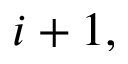<formula> <loc_0><loc_0><loc_500><loc_500>i + 1 ,</formula> 